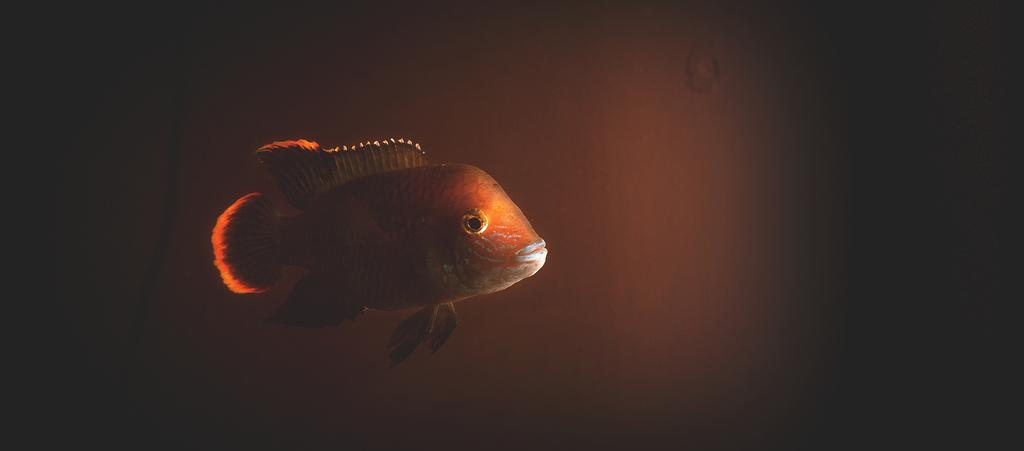What type of animal is present in the image? There is a fish in the image. What color is the fish? The fish is orange in color. How many corks can be seen floating next to the fish in the image? There are no corks present in the image; it only features a fish. Are there any dogs visible in the image? No, there are no dogs present in the image. 